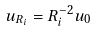Convert formula to latex. <formula><loc_0><loc_0><loc_500><loc_500>u _ { R _ { i } } = R ^ { - 2 } _ { i } u _ { 0 }</formula> 